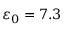<formula> <loc_0><loc_0><loc_500><loc_500>\varepsilon _ { 0 } = 7 . 3</formula> 